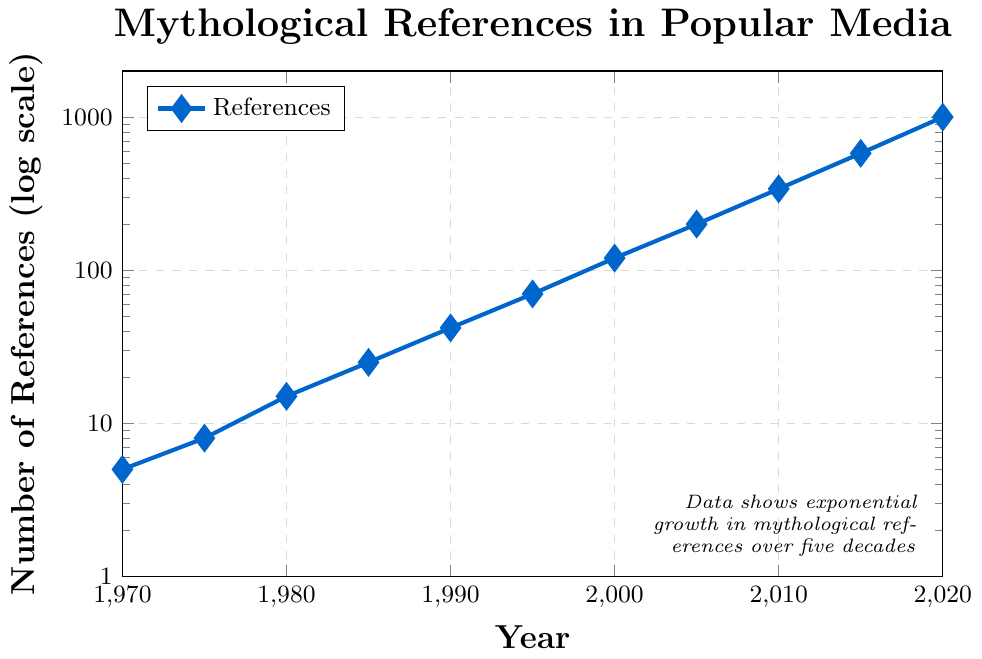What is the general trend of mythological references in popular media from 1970 to 2020? The general trend shows a consistent and exponential increase in the number of mythological references over the years. By observing the rising curve which is plotted on a logarithmic scale, one can infer continuous growth.
Answer: Exponential increase Comparing the number of mythological references in 1990 and 2000, which year had more, and by how much? The plot shows that in 1990, there were 42 references, and in 2000, there were 120 references. The difference is 120 - 42 = 78.
Answer: 2000, by 78 references By what factor did the number of mythological references increase from 1970 to 2020? The number of references in 1970 was 5 and in 2020 it was 1000. Dividing these values gives 1000 / 5 = 200, meaning the references increased by a factor of 200.
Answer: 200 How many years did it take for the number of mythological references to approximately double from 1995 to 2000? The number of references in 1995 was 70, and in 2000 it was 120. Although this isn't a clean doubling, the approximate doubling can be seen as taking about 5 years (from 1995 to 2000).
Answer: Approximately 5 years Which year saw the biggest increase in the number of mythological references compared to the previous recorded year? By comparing the differences year-by-year, 2015 saw the largest increase from the previous recorded year. The difference between 2010 (340) and 2015 (580) is 240.
Answer: 2015 What is the average number of references per recorded year from 1970 to 2020? The sum of the references is 5+8+15+25+42+70+120+200+340+580+1000 = 2405. There are 11 recorded years. Thus, the average is 2405 / 11 ≈ 218.18 references.
Answer: Approximately 218.18 references Between which consecutive recorded years did the number of mythological references increase by more than 100 for the first time? Observing the plot, the increase first exceeds 100 between 2000 (120 references) and 2005 (200 references), where the difference is 200 - 120 = 80, which is below 100. Next, between 2005 and 2010, the increase is 340 - 200 = 140.
Answer: 2005 to 2010 